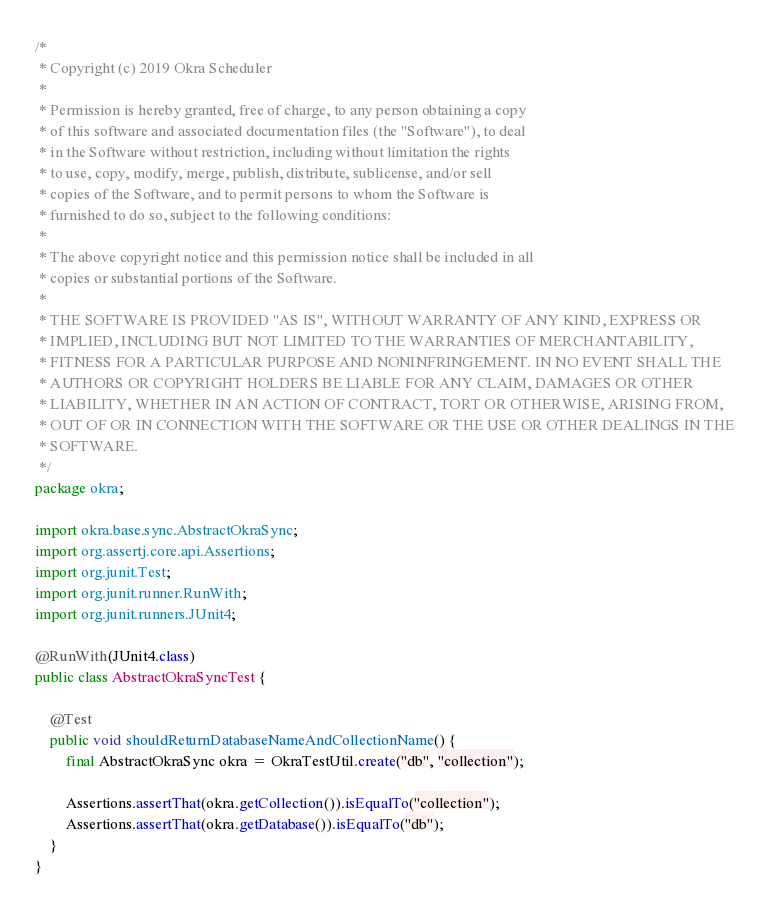Convert code to text. <code><loc_0><loc_0><loc_500><loc_500><_Java_>/*
 * Copyright (c) 2019 Okra Scheduler
 *
 * Permission is hereby granted, free of charge, to any person obtaining a copy
 * of this software and associated documentation files (the "Software"), to deal
 * in the Software without restriction, including without limitation the rights
 * to use, copy, modify, merge, publish, distribute, sublicense, and/or sell
 * copies of the Software, and to permit persons to whom the Software is
 * furnished to do so, subject to the following conditions:
 *
 * The above copyright notice and this permission notice shall be included in all
 * copies or substantial portions of the Software.
 *
 * THE SOFTWARE IS PROVIDED "AS IS", WITHOUT WARRANTY OF ANY KIND, EXPRESS OR
 * IMPLIED, INCLUDING BUT NOT LIMITED TO THE WARRANTIES OF MERCHANTABILITY,
 * FITNESS FOR A PARTICULAR PURPOSE AND NONINFRINGEMENT. IN NO EVENT SHALL THE
 * AUTHORS OR COPYRIGHT HOLDERS BE LIABLE FOR ANY CLAIM, DAMAGES OR OTHER
 * LIABILITY, WHETHER IN AN ACTION OF CONTRACT, TORT OR OTHERWISE, ARISING FROM,
 * OUT OF OR IN CONNECTION WITH THE SOFTWARE OR THE USE OR OTHER DEALINGS IN THE
 * SOFTWARE.
 */
package okra;

import okra.base.sync.AbstractOkraSync;
import org.assertj.core.api.Assertions;
import org.junit.Test;
import org.junit.runner.RunWith;
import org.junit.runners.JUnit4;

@RunWith(JUnit4.class)
public class AbstractOkraSyncTest {

    @Test
    public void shouldReturnDatabaseNameAndCollectionName() {
        final AbstractOkraSync okra = OkraTestUtil.create("db", "collection");

        Assertions.assertThat(okra.getCollection()).isEqualTo("collection");
        Assertions.assertThat(okra.getDatabase()).isEqualTo("db");
    }
}</code> 